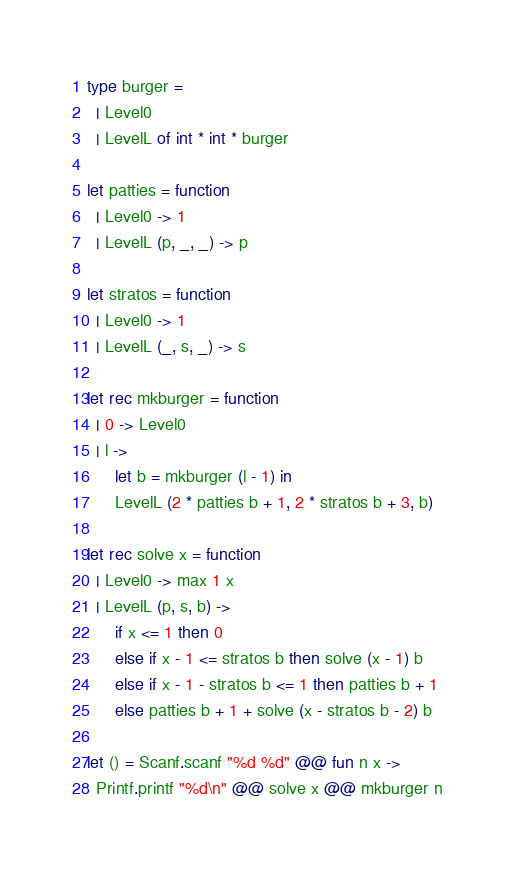<code> <loc_0><loc_0><loc_500><loc_500><_OCaml_>type burger =
  | Level0
  | LevelL of int * int * burger

let patties = function
  | Level0 -> 1
  | LevelL (p, _, _) -> p

let stratos = function
  | Level0 -> 1
  | LevelL (_, s, _) -> s

let rec mkburger = function
  | 0 -> Level0
  | l ->
      let b = mkburger (l - 1) in
      LevelL (2 * patties b + 1, 2 * stratos b + 3, b)

let rec solve x = function
  | Level0 -> max 1 x
  | LevelL (p, s, b) ->
      if x <= 1 then 0
      else if x - 1 <= stratos b then solve (x - 1) b
      else if x - 1 - stratos b <= 1 then patties b + 1
      else patties b + 1 + solve (x - stratos b - 2) b

let () = Scanf.scanf "%d %d" @@ fun n x ->
  Printf.printf "%d\n" @@ solve x @@ mkburger n
</code> 